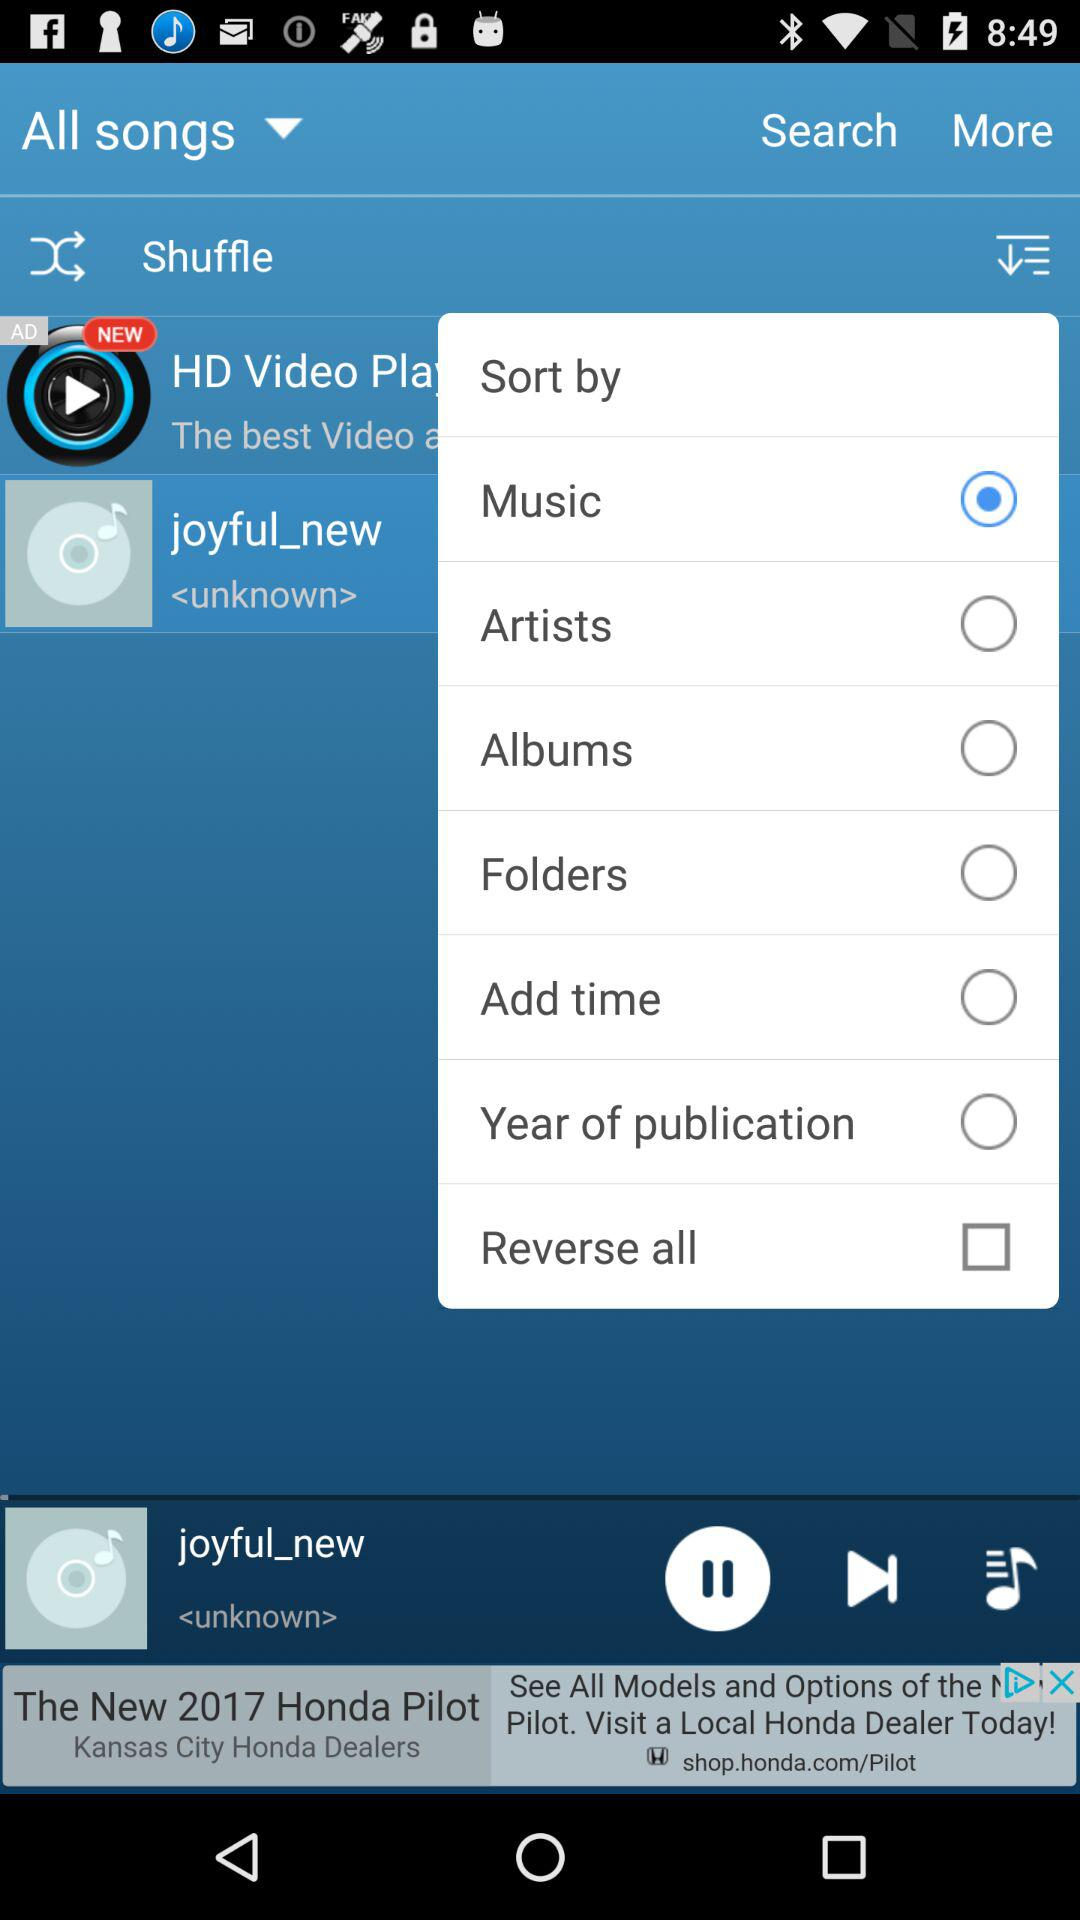What is the status of "Reverse all"? The status is "off". 